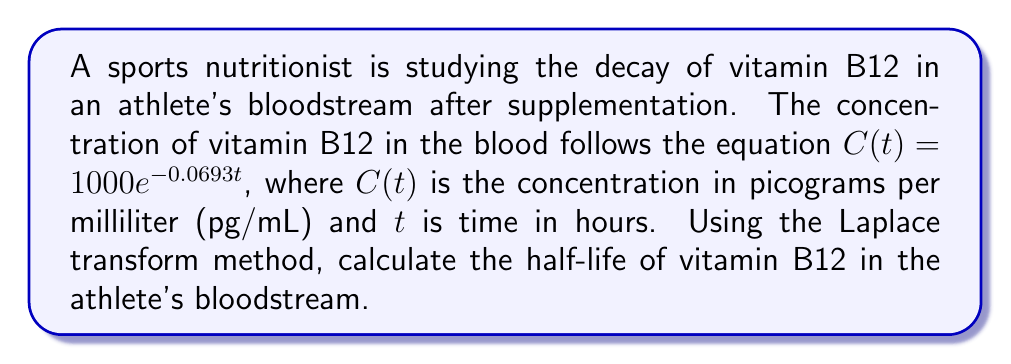Provide a solution to this math problem. To solve this problem using the Laplace transform method, we'll follow these steps:

1) The general form of exponential decay is:

   $C(t) = C_0e^{-\lambda t}$

   Where $C_0$ is the initial concentration and $\lambda$ is the decay constant.

2) In our case, $C_0 = 1000$ pg/mL and $\lambda = 0.0693$ hr^(-1).

3) The half-life $t_{1/2}$ is the time it takes for the concentration to decrease to half of its initial value. Mathematically:

   $C(t_{1/2}) = \frac{1}{2}C_0$

4) Substituting this into our original equation:

   $\frac{1}{2}C_0 = C_0e^{-\lambda t_{1/2}}$

5) Simplify:

   $\frac{1}{2} = e^{-\lambda t_{1/2}}$

6) Take the natural logarithm of both sides:

   $\ln(\frac{1}{2}) = -\lambda t_{1/2}$

7) Solve for $t_{1/2}$:

   $t_{1/2} = -\frac{\ln(\frac{1}{2})}{\lambda} = \frac{\ln(2)}{\lambda}$

8) Substitute the value of $\lambda$:

   $t_{1/2} = \frac{\ln(2)}{0.0693} \approx 10$ hours

Therefore, the half-life of vitamin B12 in the athlete's bloodstream is approximately 10 hours.
Answer: The half-life of vitamin B12 in the athlete's bloodstream is approximately 10 hours. 